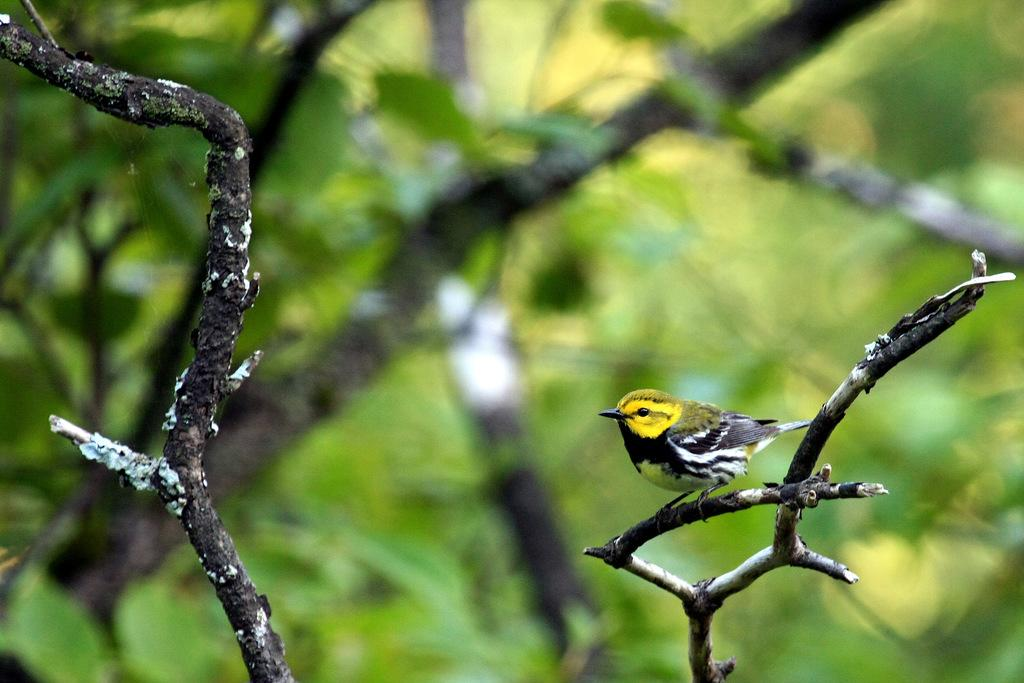What type of animal can be seen in the image? There is a bird in the image. Where is the bird located? The bird is on a tree stem. What can be observed in the background of the image? The background of the image is blurred. What color and type of vegetation is present in the image? Green leaves are visible in the image. What type of rice can be seen growing in the image? There is no rice present in the image; it features a bird on a tree stem with green leaves in the background. 